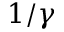<formula> <loc_0><loc_0><loc_500><loc_500>1 / \gamma</formula> 